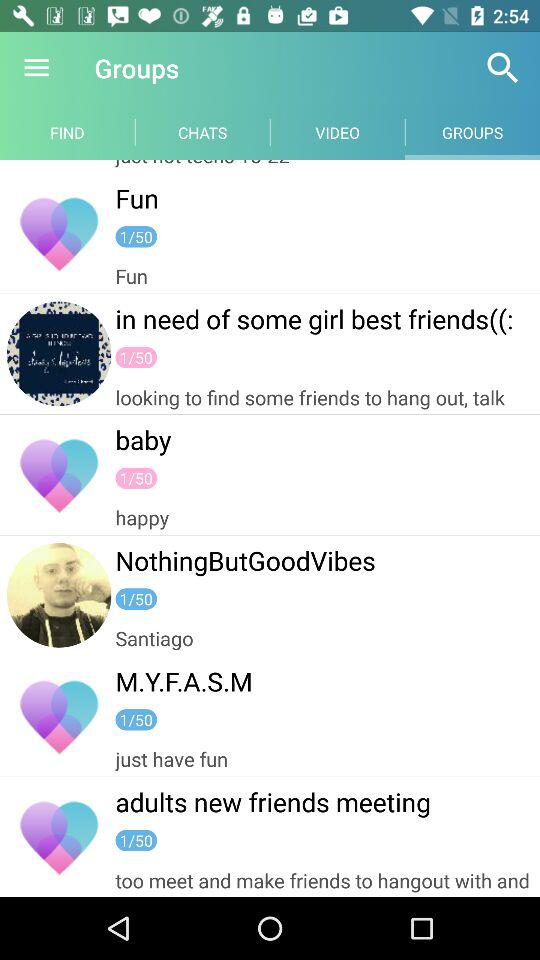How many groups are shown on the screen?
Answer the question using a single word or phrase. 6 